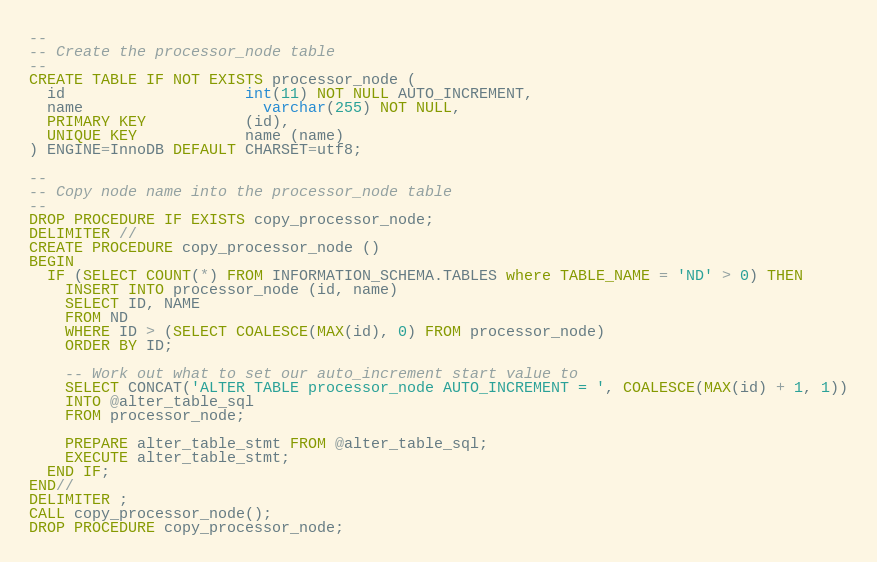<code> <loc_0><loc_0><loc_500><loc_500><_SQL_>--
-- Create the processor_node table
--
CREATE TABLE IF NOT EXISTS processor_node (
  id 				    int(11) NOT NULL AUTO_INCREMENT,
  name				    varchar(255) NOT NULL,
  PRIMARY KEY           (id),
  UNIQUE KEY            name (name)
) ENGINE=InnoDB DEFAULT CHARSET=utf8;

--
-- Copy node name into the processor_node table
--
DROP PROCEDURE IF EXISTS copy_processor_node;
DELIMITER //
CREATE PROCEDURE copy_processor_node ()
BEGIN
  IF (SELECT COUNT(*) FROM INFORMATION_SCHEMA.TABLES where TABLE_NAME = 'ND' > 0) THEN
    INSERT INTO processor_node (id, name)
    SELECT ID, NAME
    FROM ND
    WHERE ID > (SELECT COALESCE(MAX(id), 0) FROM processor_node)
    ORDER BY ID;

    -- Work out what to set our auto_increment start value to
    SELECT CONCAT('ALTER TABLE processor_node AUTO_INCREMENT = ', COALESCE(MAX(id) + 1, 1))
    INTO @alter_table_sql
    FROM processor_node;

    PREPARE alter_table_stmt FROM @alter_table_sql;
    EXECUTE alter_table_stmt;
  END IF;
END//
DELIMITER ;
CALL copy_processor_node();
DROP PROCEDURE copy_processor_node;</code> 